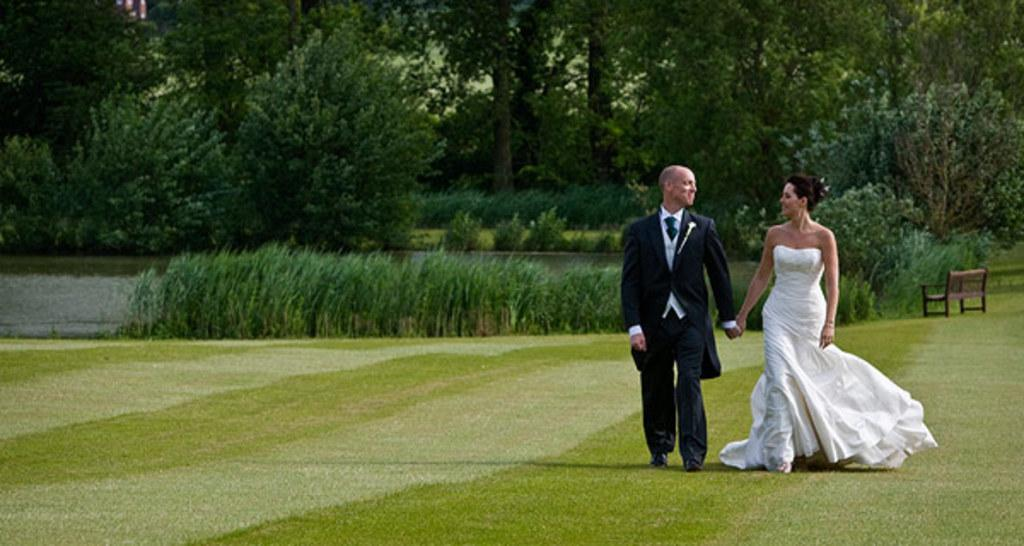What are the persons in the image doing? The persons in the image are walking in the garden. What is the emotional state of the persons in the image? The persons are smiling in the image. What can be seen in the background of the image? There are trees in the background of the image. What type of vegetation is present in the garden? There are plants in the garden. What piece of furniture is visible in the garden? There is an empty bench in the garden. What is the ground covered with in the garden? The ground has grass in the garden. What type of fruit can be seen hanging from the trees in the image? There is no fruit visible in the image; only trees are present in the background. 